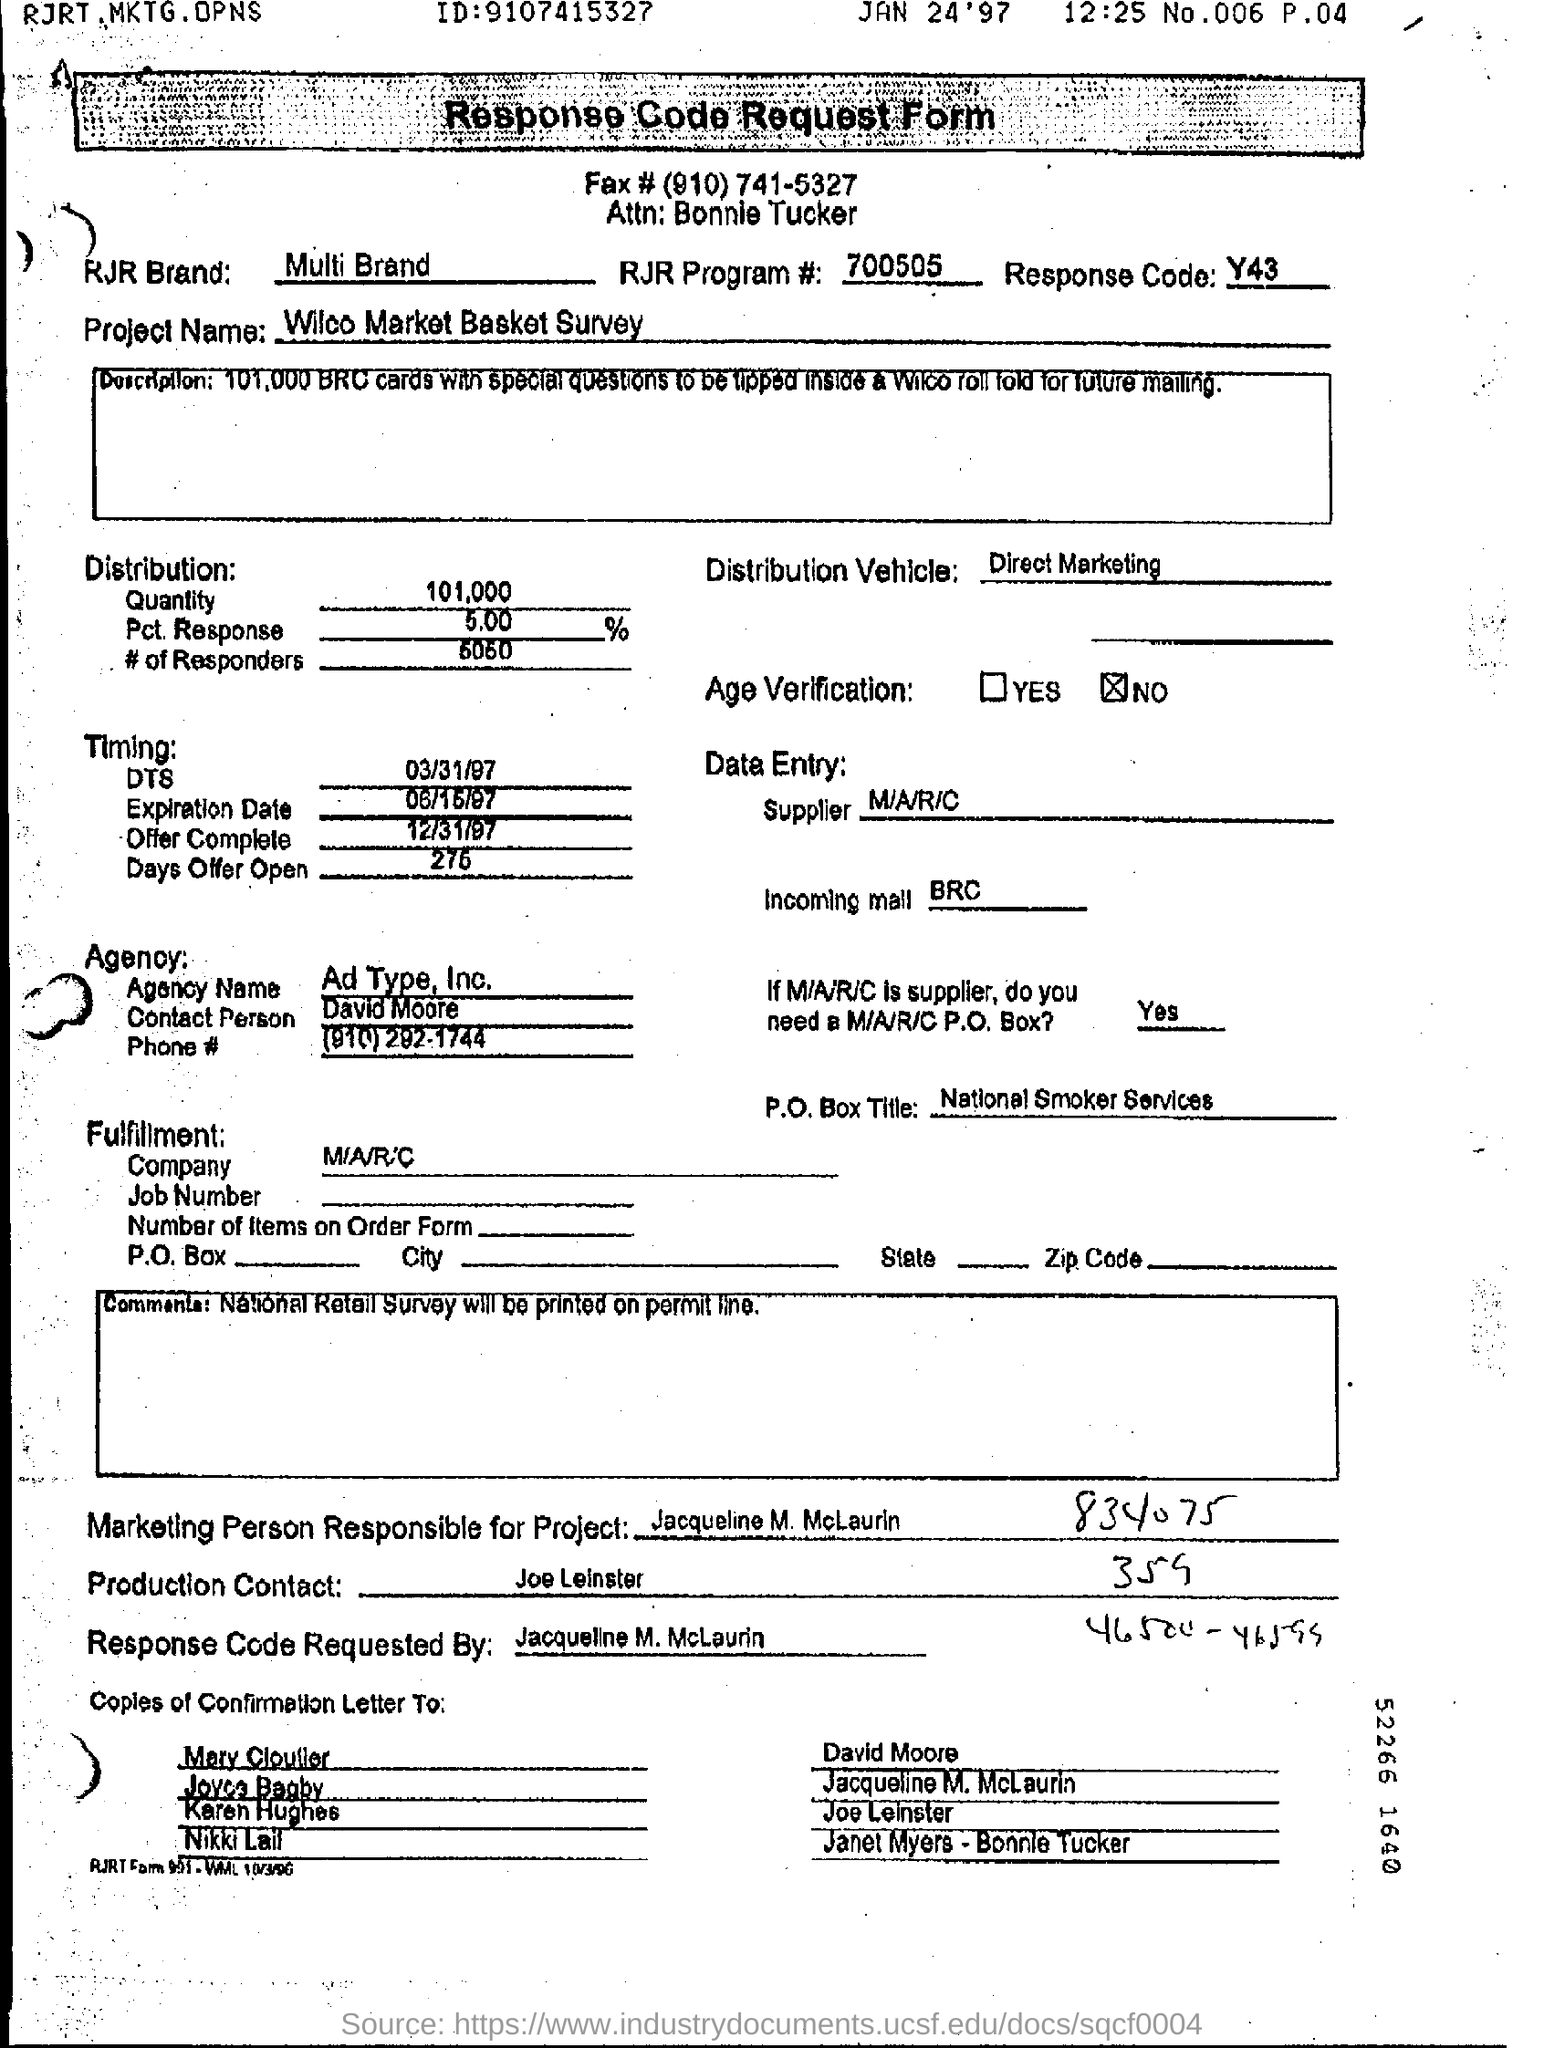What is the Response Code?
Keep it short and to the point. Y43. What is the Agency Name mentioned in the form?
Keep it short and to the point. Ad Type, Inc. Who is the Contact Person of agency?
Ensure brevity in your answer.  David Moore. Who is the Production Contact?
Ensure brevity in your answer.  Joe Leinster. 